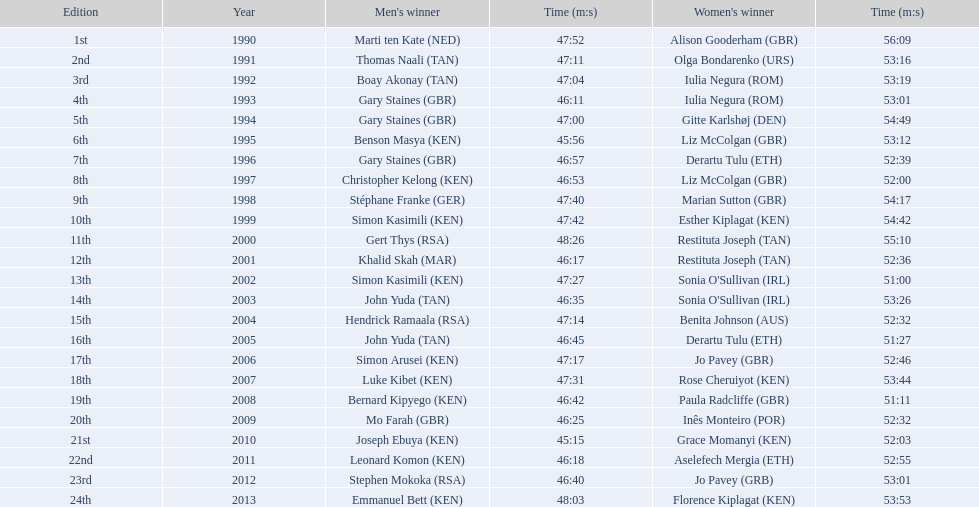What rank did sonia o'sullivan achieve in 2003? 14th. How long was her completion time? 53:26. 